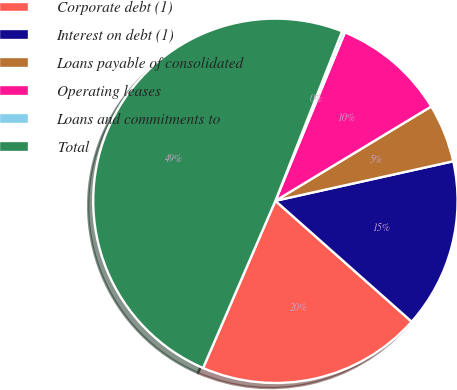<chart> <loc_0><loc_0><loc_500><loc_500><pie_chart><fcel>Corporate debt (1)<fcel>Interest on debt (1)<fcel>Loans payable of consolidated<fcel>Operating leases<fcel>Loans and commitments to<fcel>Total<nl><fcel>19.95%<fcel>15.03%<fcel>5.18%<fcel>10.11%<fcel>0.26%<fcel>49.47%<nl></chart> 